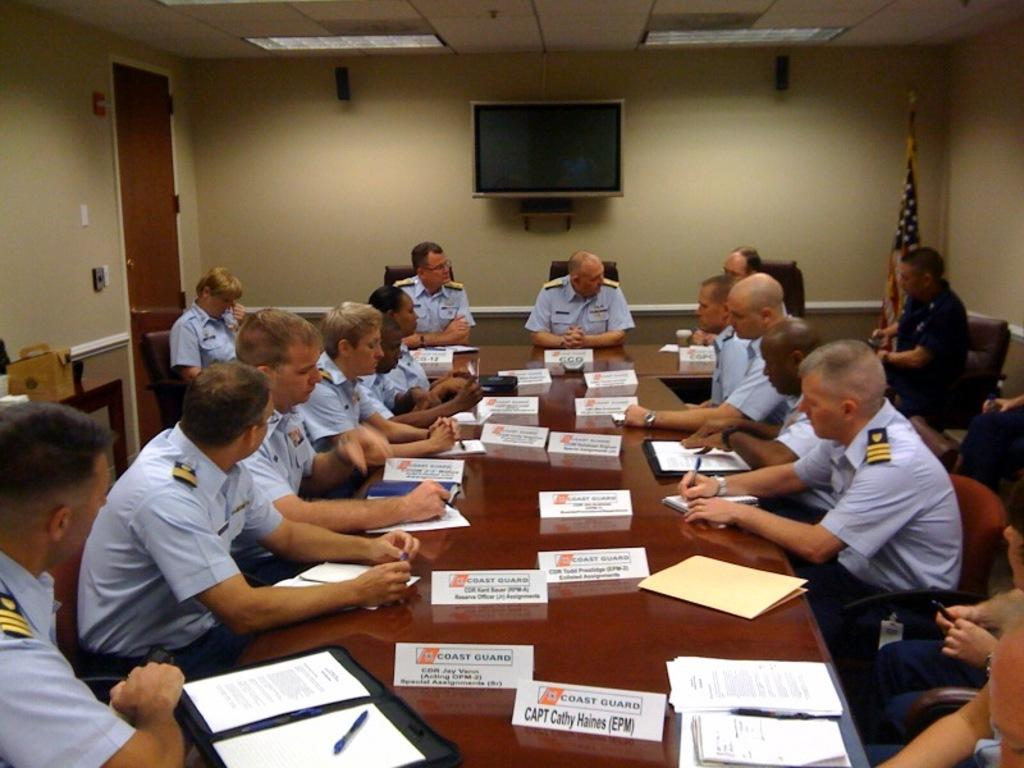Provide a one-sentence caption for the provided image. Members of the Coast Gaurd are sitting at a long table in what looks to be a meeting. 